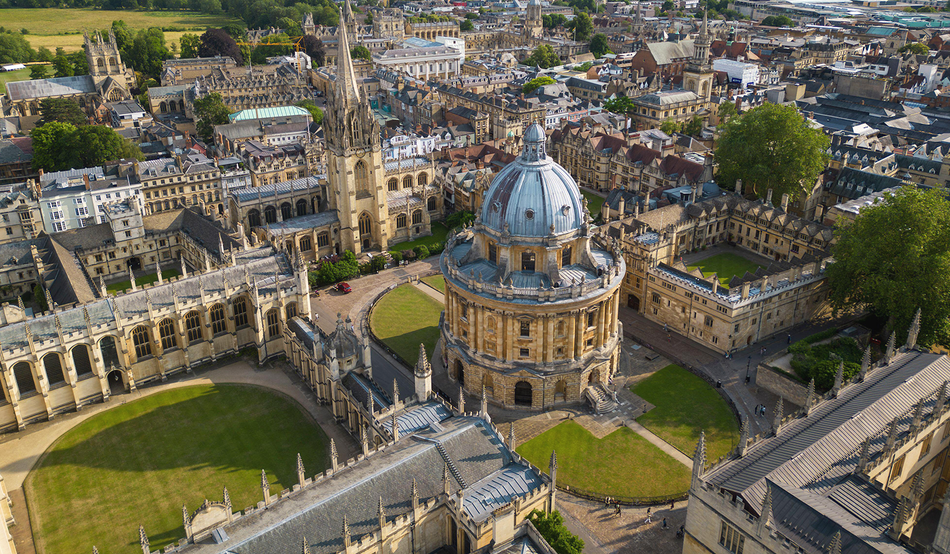Imagine you are a student at Oxford University, describe a day in your life in the context of this picture. Starting my day at Oxford University, as depicted in this image, I would wake up early to the serene view of historic buildings and lush courtyards. My first stop would be the Radcliffe Camera, where I would delve into my studies within its vast collection of books and tranquil reading rooms. Following a productive study session, I would meet friends for a stroll through the manicured gardens, discussing lectures and exchanging ideas. Lunch in one of the cozy campus cafes would provide a pleasant break before attending afternoon classes in the nearby Renaissance-style buildings. The day would end with a quiet walk back to my residence, reflecting on the day amidst the timeless beauty that surrounds me, inspired by the legacy of scholars who walked these paths before me.  Imagine you are a historian exploring the university. How would you analyze the architecture and its history depicted in this image? As a historian, I would be captivated by the architectural elegance and historical significance of Oxford University's buildings as seen in this image. The Radcliffe Camera, with its Palladian design elements, reflects the influence of classical architecture and the Enlightenment era's pursuit of knowledge. Examining the surrounding Gothic and Renaissance-style structures, I would note the elaborate carvings, spires, and facades that tell stories of different architectural movements and periods. Each building would be a testament to the university's evolving history, from medieval times to modern-day. By analyzing these architectural details and their historical contexts, I would gain deeper insights into how the university's physical form has been shaped by centuries of academic tradition, cultural shifts, and societal values. 